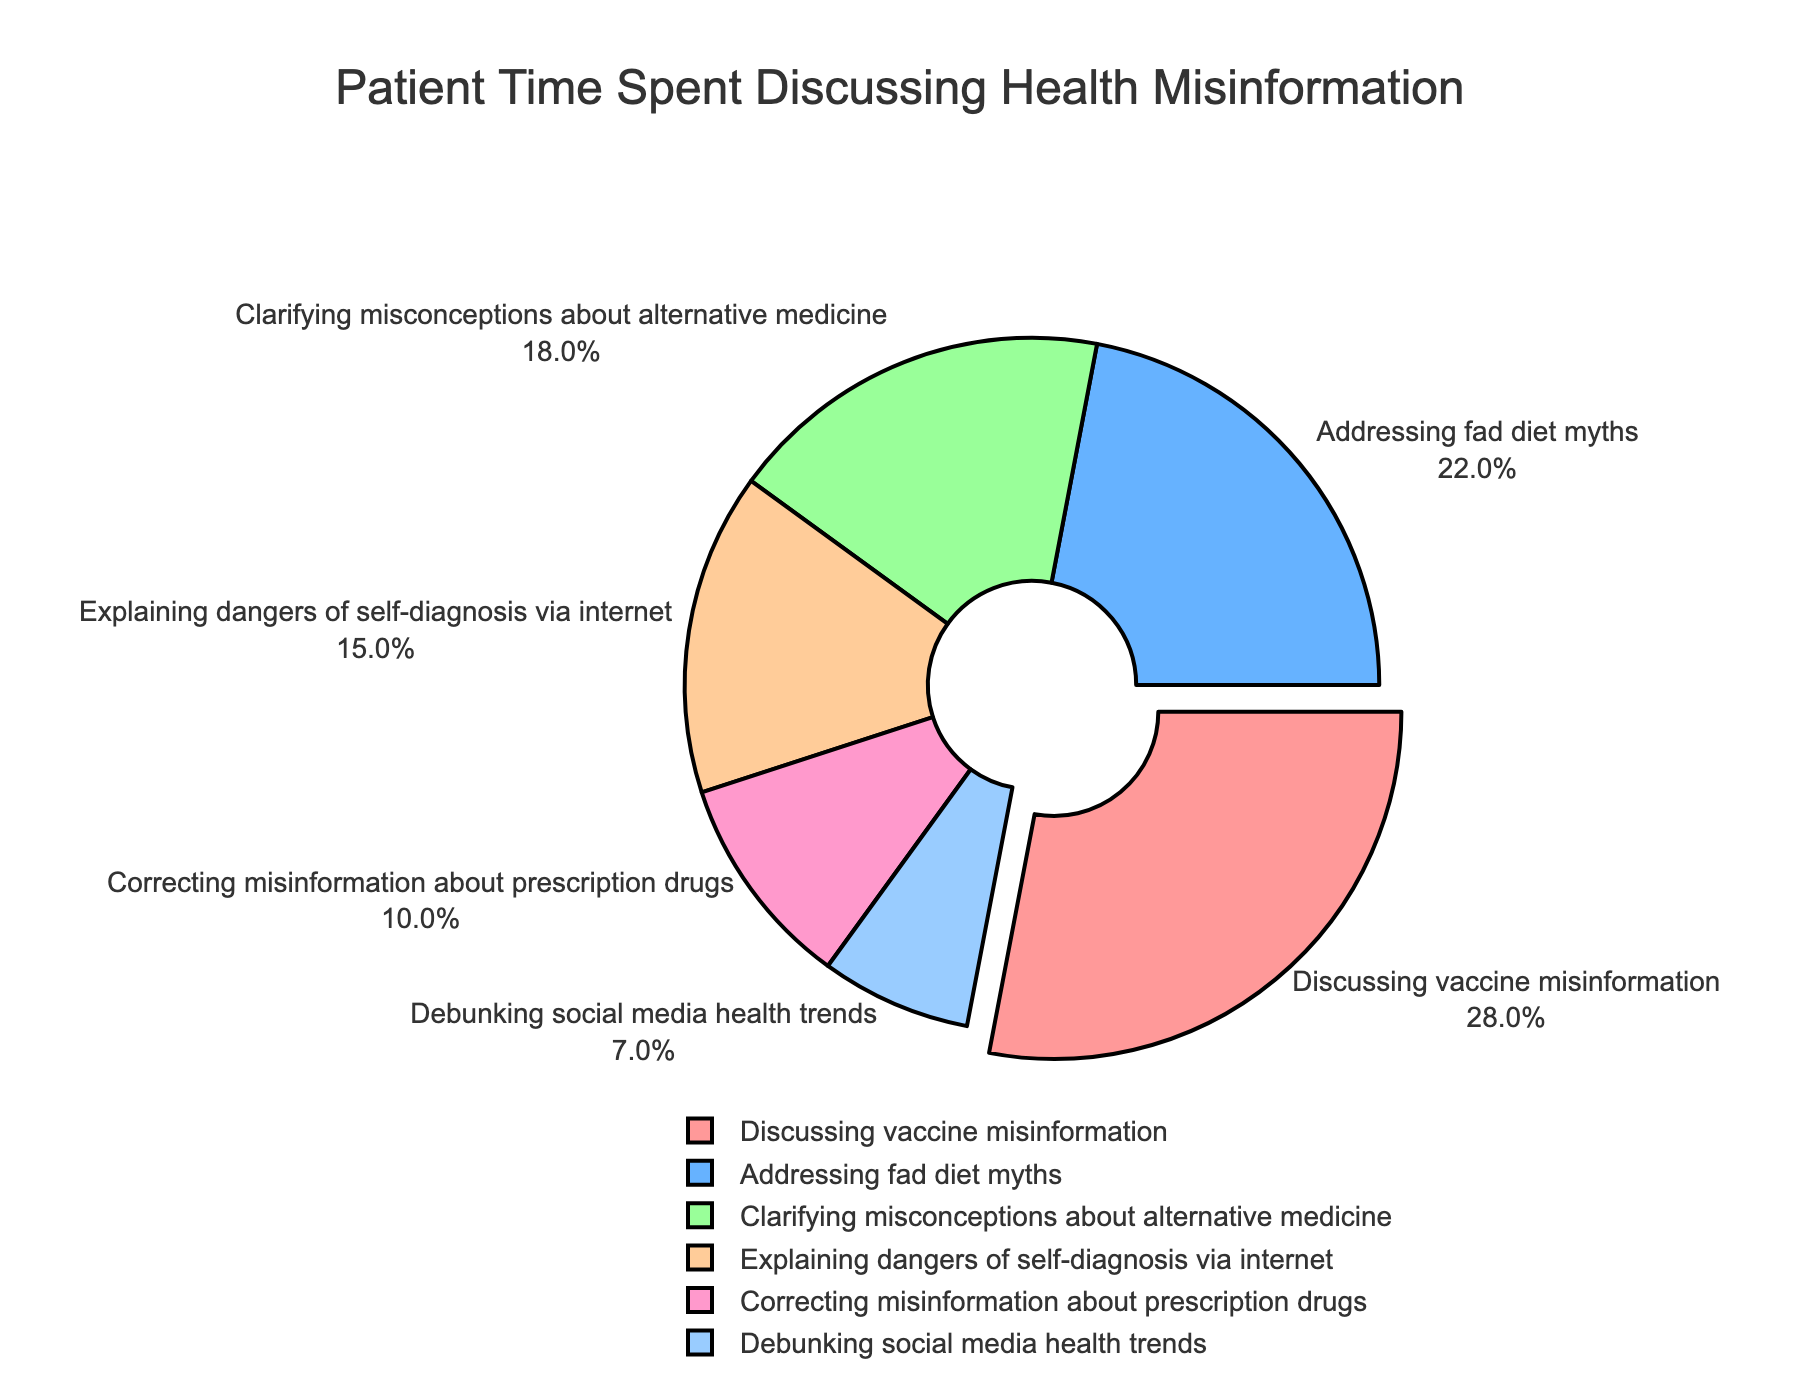Which topic takes up the largest percentage of patient time? Look at the slice with the largest percentage value in the pie chart. "Discussing vaccine misinformation" takes up 28%, which is the largest slice.
Answer: Discussing vaccine misinformation What is the total percentage of patient time spent discussing "Addressing fad diet myths" and "Clarifying misconceptions about alternative medicine"? Sum the percentages of "Addressing fad diet myths" (22%) and "Clarifying misconceptions about alternative medicine" (18%). 22% + 18% = 40%.
Answer: 40% Which topic takes up the smallest percentage of patient time? Look for the smallest slice in the pie chart. "Debunking social media health trends" takes up 7%, which is the smallest slice.
Answer: Debunking social media health trends How much more time is spent discussing "Explaining dangers of self-diagnosis via internet" compared to "Correcting misinformation about prescription drugs"? Subtract the percentage of "Correcting misinformation about prescription drugs" (10%) from the percentage of "Explaining dangers of self-diagnosis via internet" (15%). 15% - 10% = 5%.
Answer: 5% What percentage of patient time is spent on topics other than "Discussing vaccine misinformation"? Subtract the percentage of "Discussing vaccine misinformation" (28%) from 100%. 100% - 28% = 72%.
Answer: 72% What is the average percentage of time spent across all six topics? Add up all the percentages and then divide by the number of topics (6). (28% + 22% + 18% + 15% + 10% + 7%) / 6 = 100% / 6 ≈ 16.67%.
Answer: ~16.67% Among the topics, which one is marked by a different visual attribute in the pie chart? Notice that one slice is "pulled out" from the rest of the chart, which distinguishes it visually. The "Discussing vaccine misinformation" slice is the one that is pulled out.
Answer: Discussing vaccine misinformation Which two topics combined make up less than half of the patient time? Add up the percentages of various combinations and find the one under 50%. "Correcting misinformation about prescription drugs" (10%) and "Debunking social media health trends" (7%) together make up 17%, which is less than half.
Answer: Correcting misinformation about prescription drugs and Debunking social media health trends What is the total percentage of time spent discussing "Explaining dangers of self-diagnosis via internet" and "Addressing fad diet myths"? Sum the percentages of "Explaining dangers of self-diagnosis via internet" (15%) and "Addressing fad diet myths" (22%). 15% + 22% = 37%.
Answer: 37% 